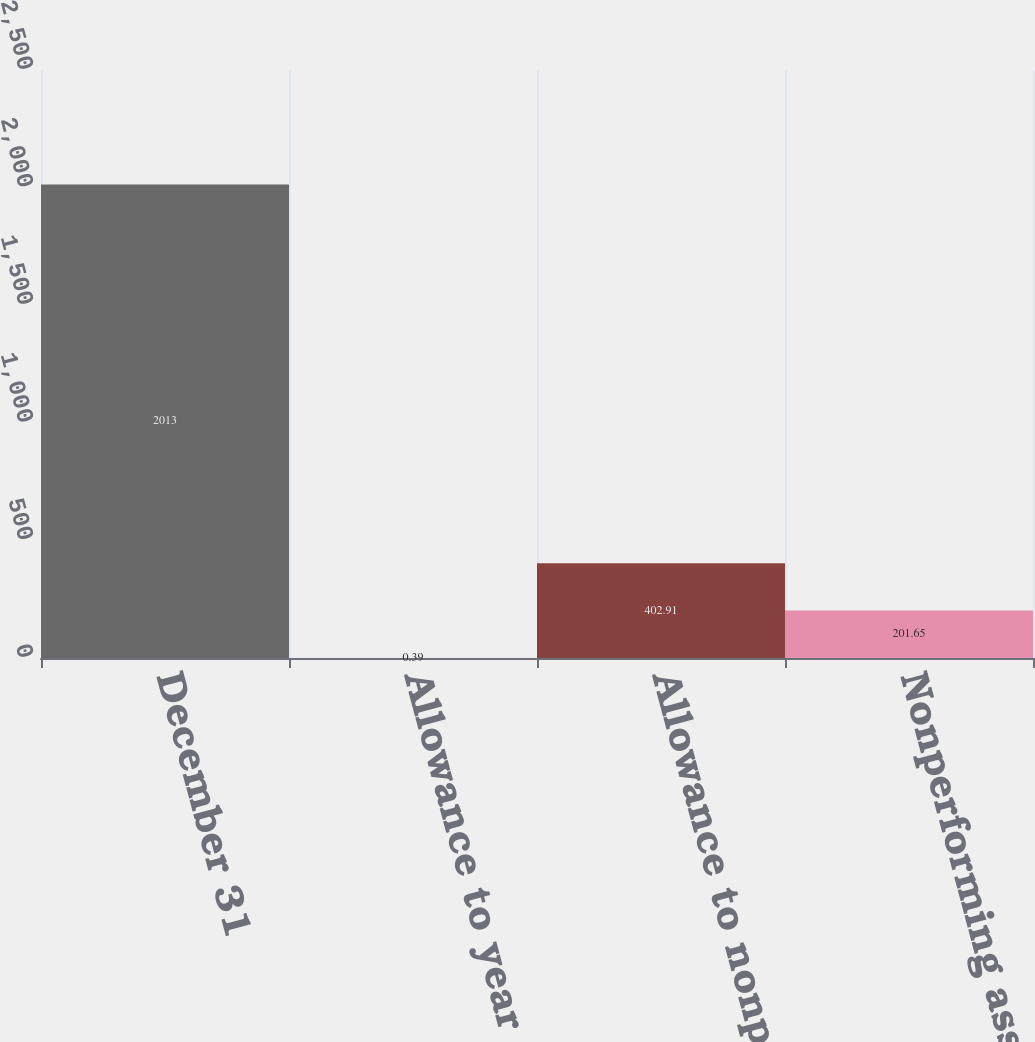Convert chart. <chart><loc_0><loc_0><loc_500><loc_500><bar_chart><fcel>December 31<fcel>Allowance to year end loans<fcel>Allowance to nonperforming<fcel>Nonperforming assets to<nl><fcel>2013<fcel>0.39<fcel>402.91<fcel>201.65<nl></chart> 